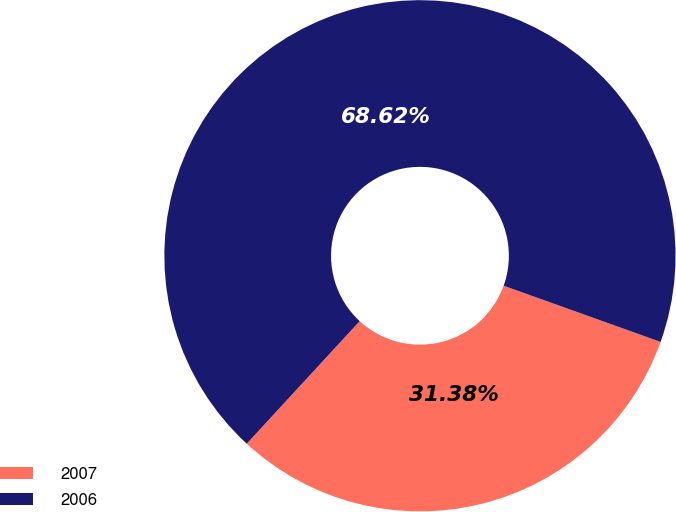<chart> <loc_0><loc_0><loc_500><loc_500><pie_chart><fcel>2007<fcel>2006<nl><fcel>31.38%<fcel>68.62%<nl></chart> 